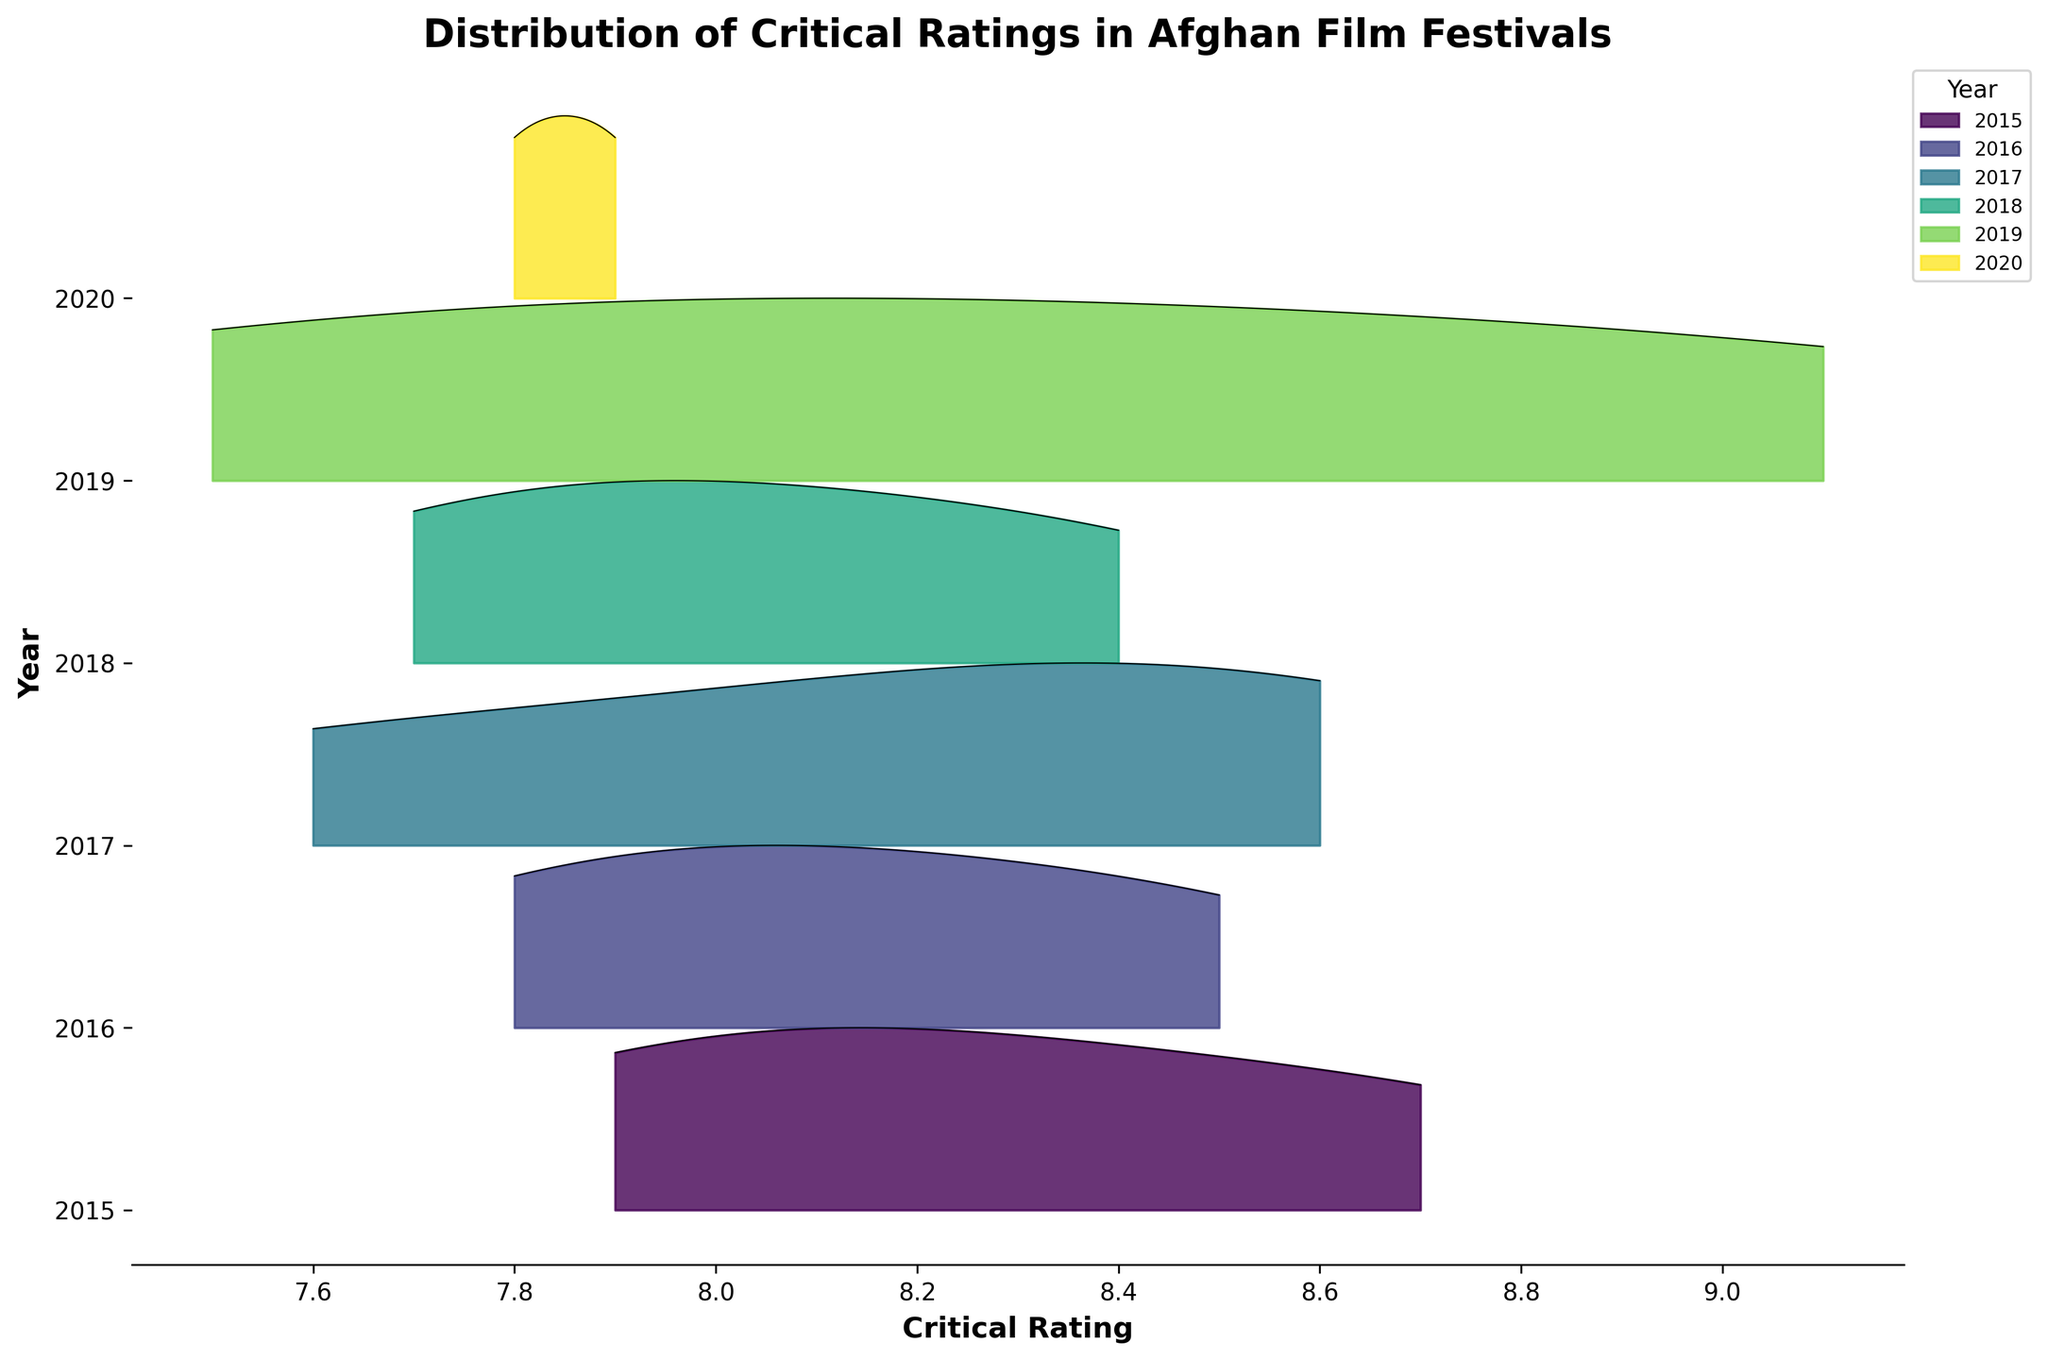What's the title of the figure? The title is located at the top of the figure. It describes what the figure is about.
Answer: Distribution of Critical Ratings in Afghan Film Festivals What's the range of the critical ratings? You can deduce the range by looking at the x-axis, which shows the minimum and maximum critical rating values.
Answer: 7.5 to 9.1 How many unique years are represented in the data? The years are indicated on the y-axis, and each unique tick mark corresponds to a distinct year.
Answer: 6 Which year has the film with the highest critical rating? You need to look for the highest peak along the x-axis and then trace it back to the corresponding year on the y-axis.
Answer: 2019 Which years have overlapping rating distributions? Observe the ridgelines that intersect or have ranges that overlap along the x-axis.
Answer: 2018 and 2020 What is the general shape of the distribution for the year 2017? Trace the ridgeline corresponding to 2017 and observe its spread and peak pattern along the x-axis.
Answer: Skewed to the right In which year do the films have the most spread in their ratings? Check for the year where the ridgeline has the widest base along the x-axis.
Answer: 2015 How do the average critical ratings compare between 2016 and 2019? Assess the central tendency (mean) of the ridgelines for 2016 and 2019 and compare their positions along the x-axis.
Answer: 2019 is higher Which year shows the least variation in film ratings? The year with the narrowest ridgeline, without prominent peaks or troughs, indicates the least variation.
Answer: 2020 What trend can be observed in the film ratings from 2015 to 2020? Observe the shifts in the central tendencies and spreads of the ridgelines from 2015 to 2020 along the x-axis to discern any patterns.
Answer: Increasing trend 